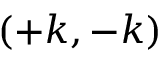Convert formula to latex. <formula><loc_0><loc_0><loc_500><loc_500>( + k , - k )</formula> 